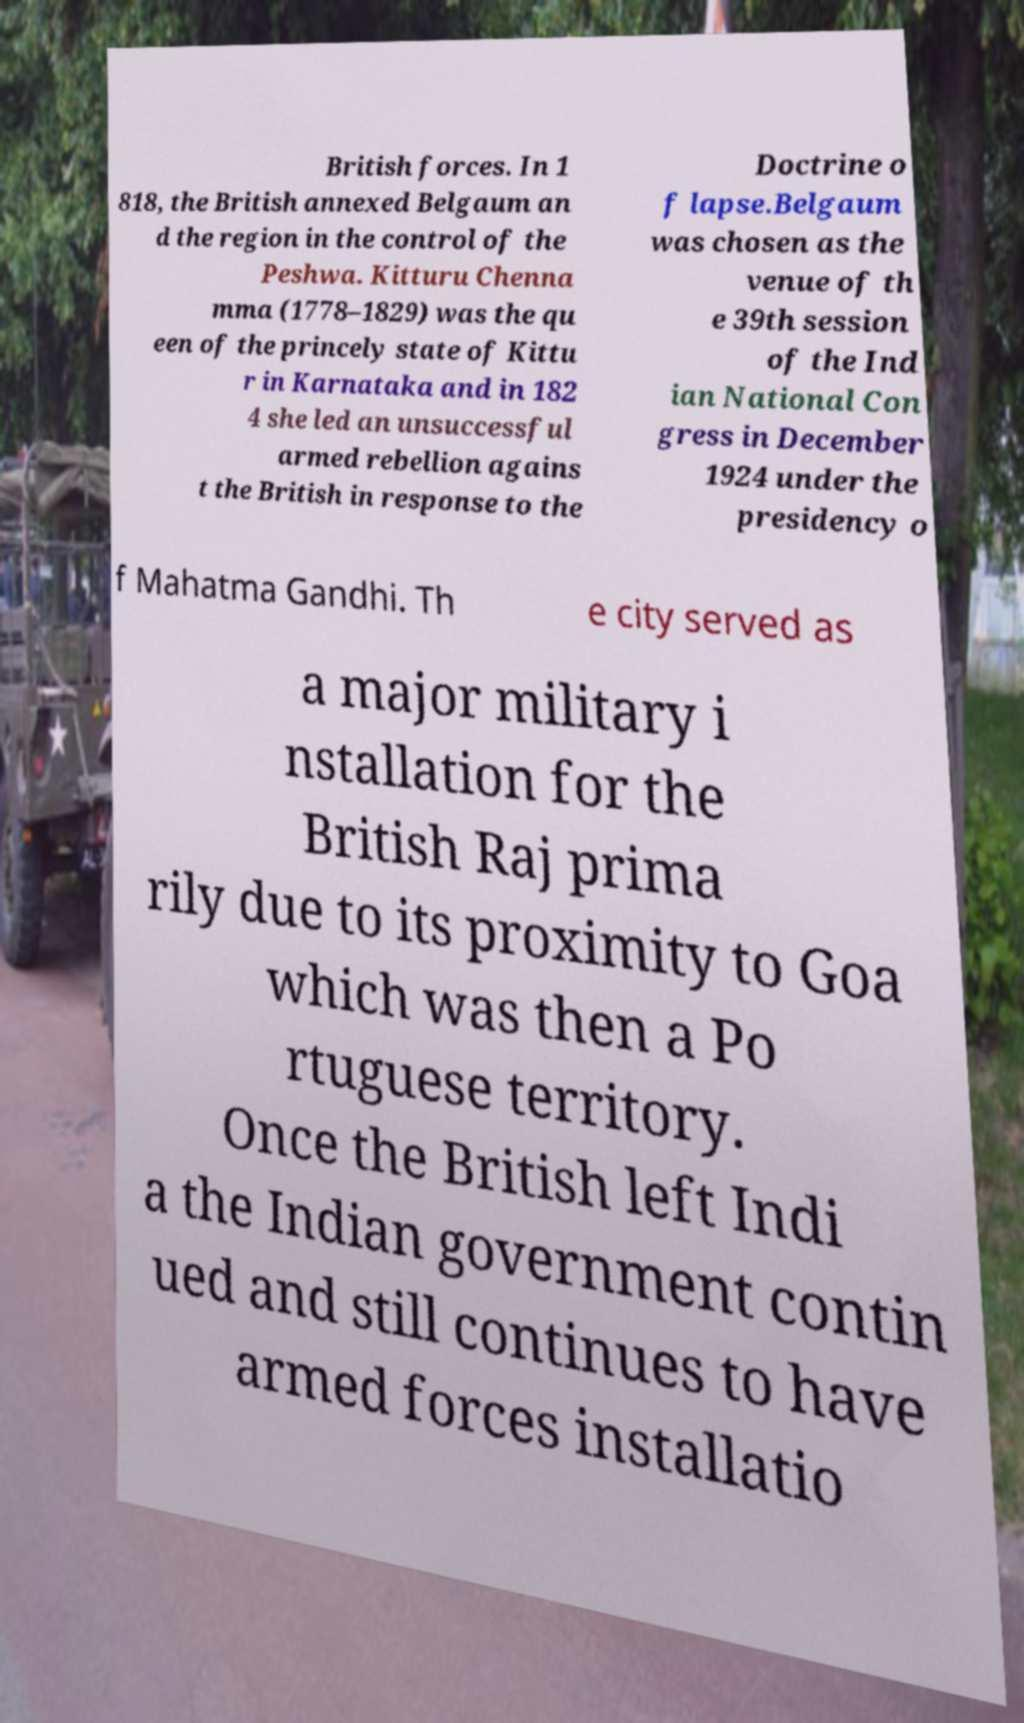There's text embedded in this image that I need extracted. Can you transcribe it verbatim? British forces. In 1 818, the British annexed Belgaum an d the region in the control of the Peshwa. Kitturu Chenna mma (1778–1829) was the qu een of the princely state of Kittu r in Karnataka and in 182 4 she led an unsuccessful armed rebellion agains t the British in response to the Doctrine o f lapse.Belgaum was chosen as the venue of th e 39th session of the Ind ian National Con gress in December 1924 under the presidency o f Mahatma Gandhi. Th e city served as a major military i nstallation for the British Raj prima rily due to its proximity to Goa which was then a Po rtuguese territory. Once the British left Indi a the Indian government contin ued and still continues to have armed forces installatio 